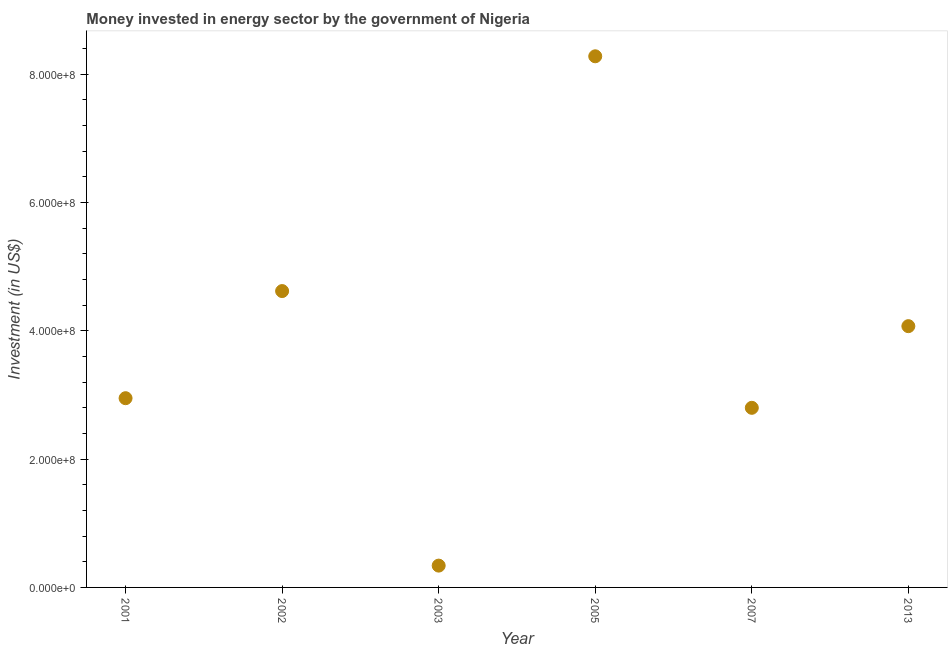What is the investment in energy in 2005?
Keep it short and to the point. 8.28e+08. Across all years, what is the maximum investment in energy?
Give a very brief answer. 8.28e+08. Across all years, what is the minimum investment in energy?
Your response must be concise. 3.40e+07. In which year was the investment in energy minimum?
Provide a short and direct response. 2003. What is the sum of the investment in energy?
Provide a short and direct response. 2.31e+09. What is the difference between the investment in energy in 2003 and 2005?
Offer a very short reply. -7.94e+08. What is the average investment in energy per year?
Your answer should be very brief. 3.84e+08. What is the median investment in energy?
Make the answer very short. 3.51e+08. In how many years, is the investment in energy greater than 480000000 US$?
Provide a short and direct response. 1. Do a majority of the years between 2007 and 2005 (inclusive) have investment in energy greater than 280000000 US$?
Offer a terse response. No. What is the ratio of the investment in energy in 2005 to that in 2013?
Your response must be concise. 2.03. Is the investment in energy in 2003 less than that in 2013?
Your answer should be very brief. Yes. Is the difference between the investment in energy in 2002 and 2005 greater than the difference between any two years?
Your answer should be compact. No. What is the difference between the highest and the second highest investment in energy?
Your answer should be very brief. 3.66e+08. What is the difference between the highest and the lowest investment in energy?
Ensure brevity in your answer.  7.94e+08. What is the difference between two consecutive major ticks on the Y-axis?
Keep it short and to the point. 2.00e+08. Does the graph contain any zero values?
Provide a succinct answer. No. What is the title of the graph?
Your answer should be compact. Money invested in energy sector by the government of Nigeria. What is the label or title of the Y-axis?
Offer a terse response. Investment (in US$). What is the Investment (in US$) in 2001?
Keep it short and to the point. 2.95e+08. What is the Investment (in US$) in 2002?
Keep it short and to the point. 4.62e+08. What is the Investment (in US$) in 2003?
Offer a terse response. 3.40e+07. What is the Investment (in US$) in 2005?
Your answer should be very brief. 8.28e+08. What is the Investment (in US$) in 2007?
Make the answer very short. 2.80e+08. What is the Investment (in US$) in 2013?
Provide a succinct answer. 4.07e+08. What is the difference between the Investment (in US$) in 2001 and 2002?
Your response must be concise. -1.67e+08. What is the difference between the Investment (in US$) in 2001 and 2003?
Offer a terse response. 2.61e+08. What is the difference between the Investment (in US$) in 2001 and 2005?
Offer a very short reply. -5.33e+08. What is the difference between the Investment (in US$) in 2001 and 2007?
Offer a terse response. 1.50e+07. What is the difference between the Investment (in US$) in 2001 and 2013?
Your answer should be very brief. -1.12e+08. What is the difference between the Investment (in US$) in 2002 and 2003?
Provide a short and direct response. 4.28e+08. What is the difference between the Investment (in US$) in 2002 and 2005?
Your answer should be very brief. -3.66e+08. What is the difference between the Investment (in US$) in 2002 and 2007?
Your answer should be compact. 1.82e+08. What is the difference between the Investment (in US$) in 2002 and 2013?
Offer a terse response. 5.47e+07. What is the difference between the Investment (in US$) in 2003 and 2005?
Offer a terse response. -7.94e+08. What is the difference between the Investment (in US$) in 2003 and 2007?
Your response must be concise. -2.46e+08. What is the difference between the Investment (in US$) in 2003 and 2013?
Provide a succinct answer. -3.73e+08. What is the difference between the Investment (in US$) in 2005 and 2007?
Your answer should be compact. 5.48e+08. What is the difference between the Investment (in US$) in 2005 and 2013?
Give a very brief answer. 4.21e+08. What is the difference between the Investment (in US$) in 2007 and 2013?
Your answer should be very brief. -1.27e+08. What is the ratio of the Investment (in US$) in 2001 to that in 2002?
Provide a short and direct response. 0.64. What is the ratio of the Investment (in US$) in 2001 to that in 2003?
Give a very brief answer. 8.68. What is the ratio of the Investment (in US$) in 2001 to that in 2005?
Your answer should be very brief. 0.36. What is the ratio of the Investment (in US$) in 2001 to that in 2007?
Offer a terse response. 1.05. What is the ratio of the Investment (in US$) in 2001 to that in 2013?
Your answer should be compact. 0.72. What is the ratio of the Investment (in US$) in 2002 to that in 2003?
Your answer should be very brief. 13.59. What is the ratio of the Investment (in US$) in 2002 to that in 2005?
Keep it short and to the point. 0.56. What is the ratio of the Investment (in US$) in 2002 to that in 2007?
Keep it short and to the point. 1.65. What is the ratio of the Investment (in US$) in 2002 to that in 2013?
Your response must be concise. 1.13. What is the ratio of the Investment (in US$) in 2003 to that in 2005?
Make the answer very short. 0.04. What is the ratio of the Investment (in US$) in 2003 to that in 2007?
Your answer should be very brief. 0.12. What is the ratio of the Investment (in US$) in 2003 to that in 2013?
Provide a short and direct response. 0.08. What is the ratio of the Investment (in US$) in 2005 to that in 2007?
Offer a terse response. 2.96. What is the ratio of the Investment (in US$) in 2005 to that in 2013?
Your answer should be very brief. 2.03. What is the ratio of the Investment (in US$) in 2007 to that in 2013?
Give a very brief answer. 0.69. 